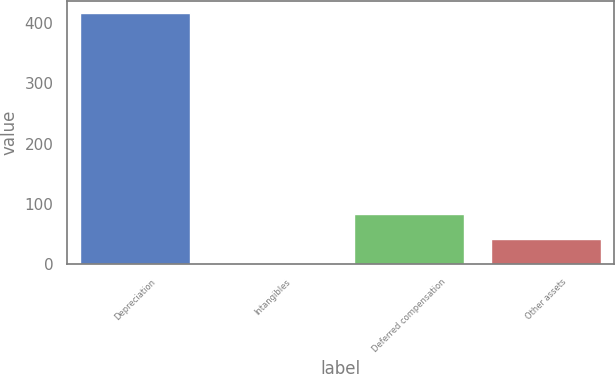Convert chart to OTSL. <chart><loc_0><loc_0><loc_500><loc_500><bar_chart><fcel>Depreciation<fcel>Intangibles<fcel>Deferred compensation<fcel>Other assets<nl><fcel>416<fcel>1<fcel>84<fcel>42.5<nl></chart> 